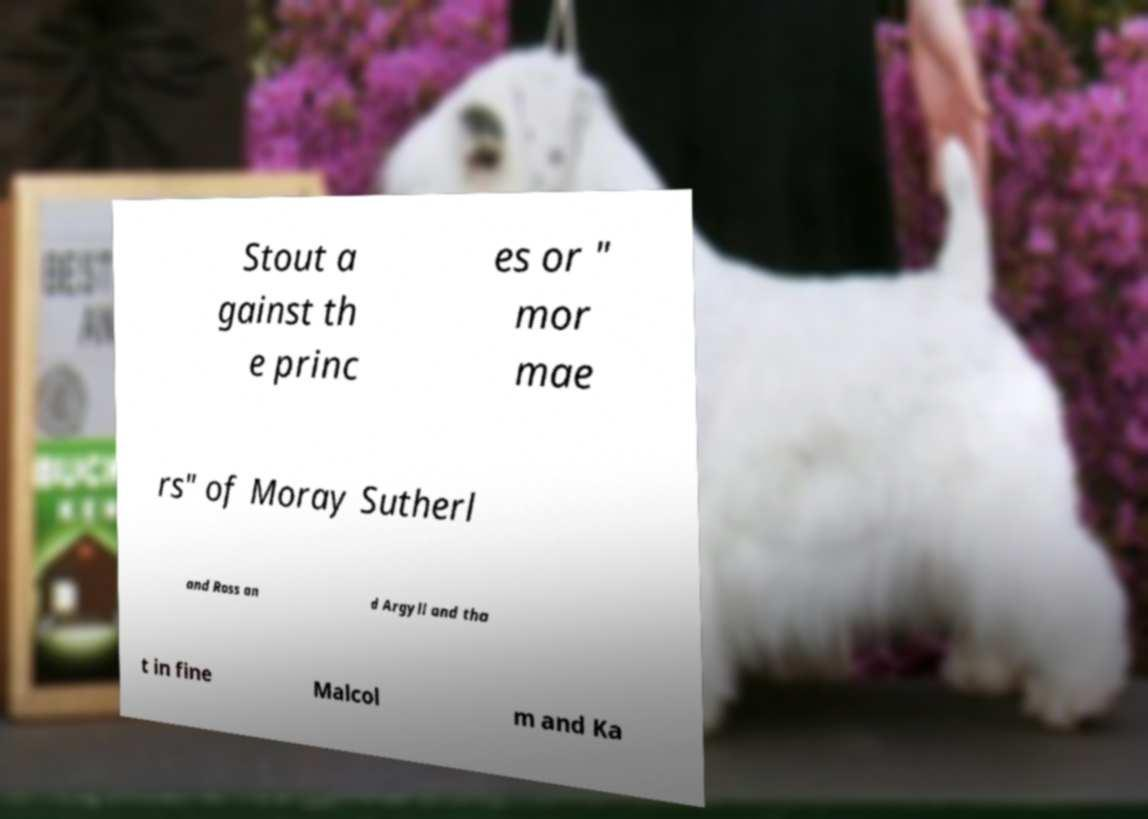Could you extract and type out the text from this image? Stout a gainst th e princ es or " mor mae rs" of Moray Sutherl and Ross an d Argyll and tha t in fine Malcol m and Ka 